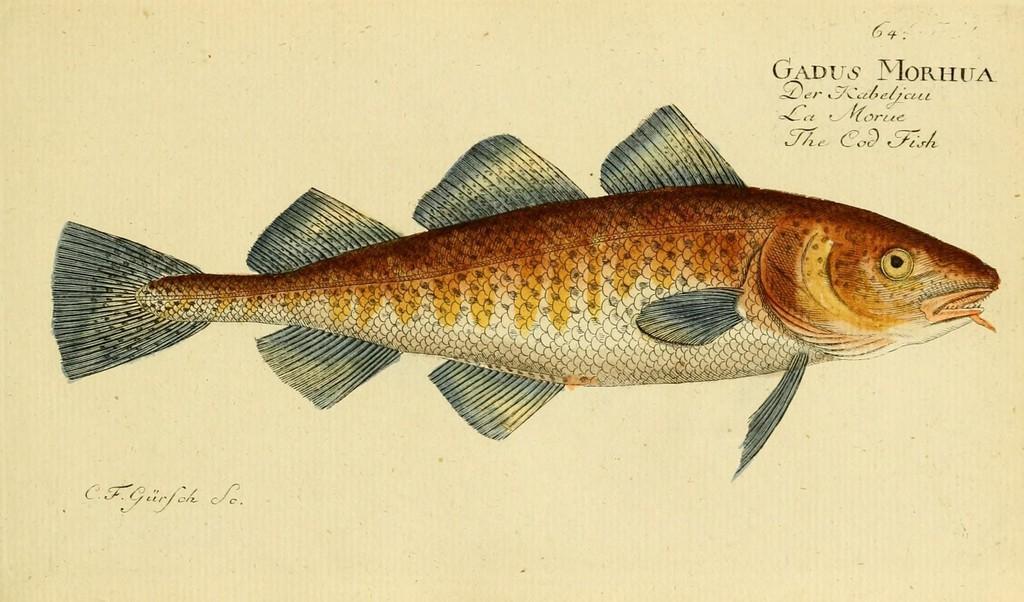Can you describe this image briefly? This is an animated image in this image in the center there is one fish, and on the top and bottom of the image there is some text. 